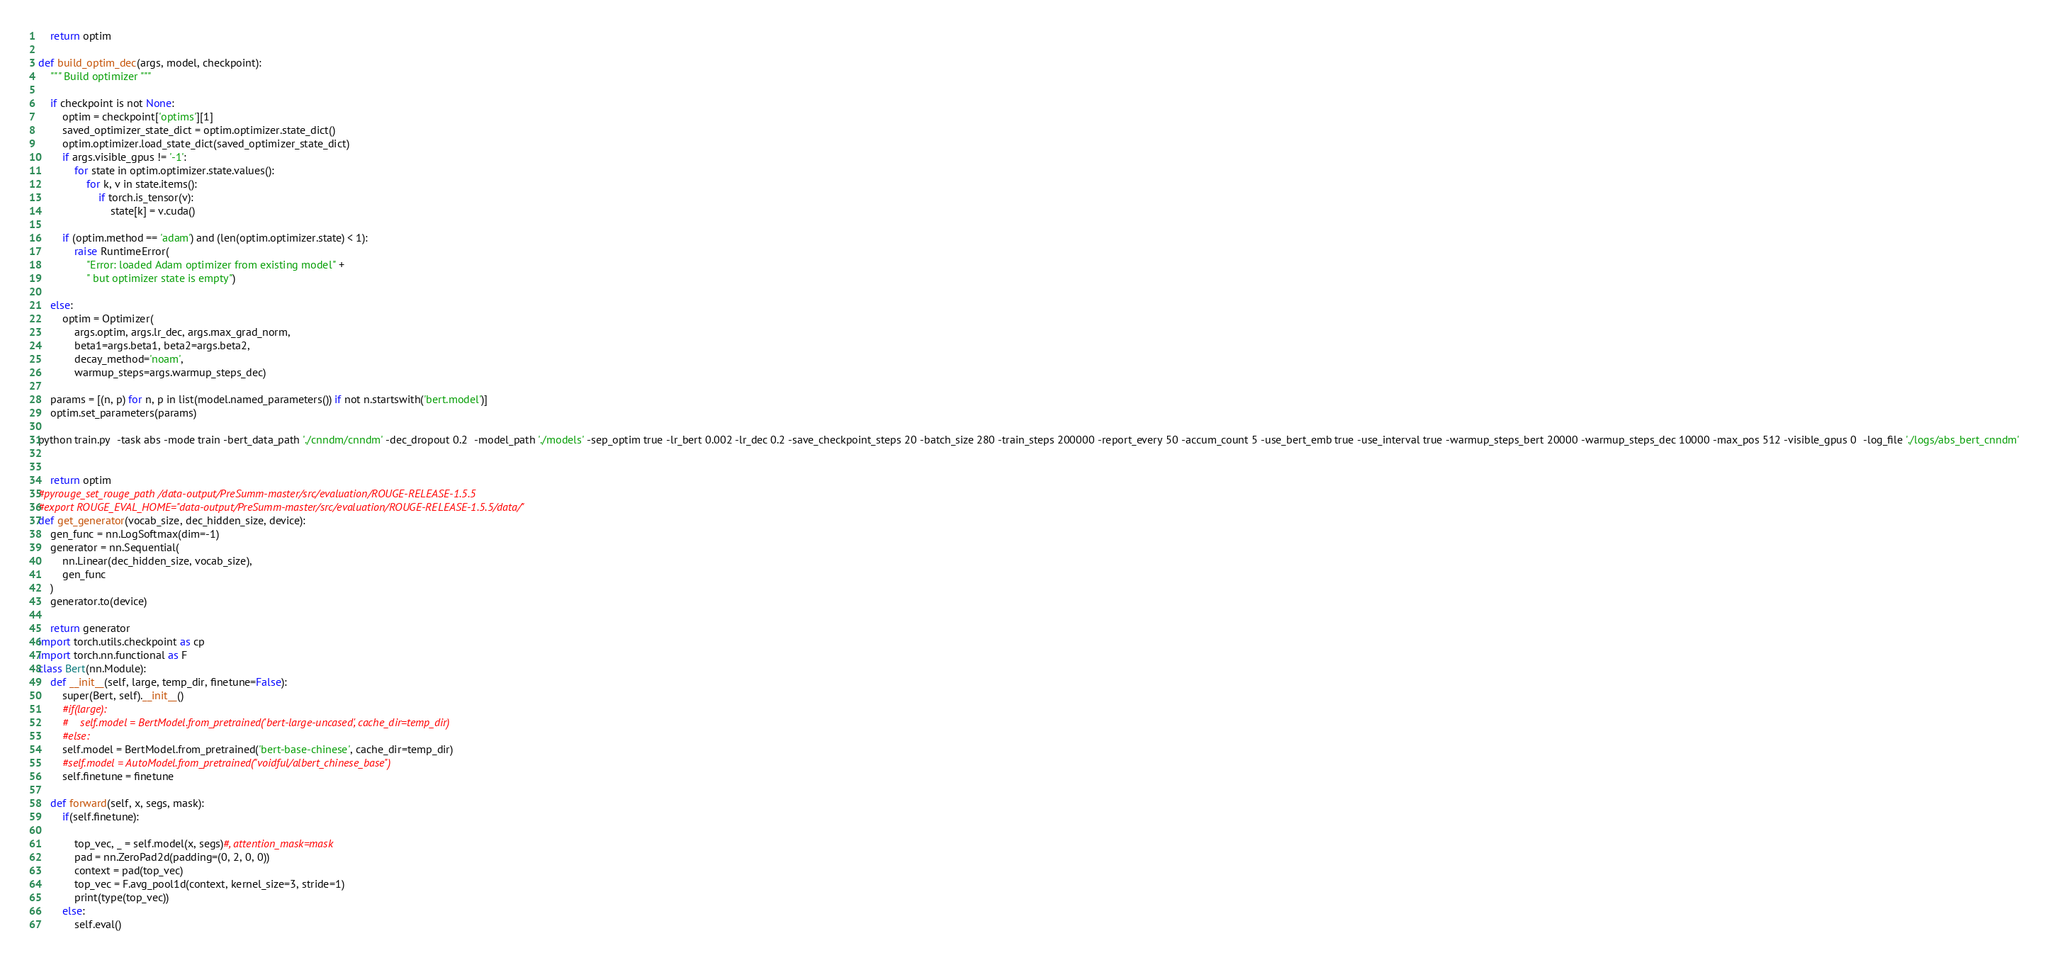Convert code to text. <code><loc_0><loc_0><loc_500><loc_500><_Python_>

    return optim

def build_optim_dec(args, model, checkpoint):
    """ Build optimizer """

    if checkpoint is not None:
        optim = checkpoint['optims'][1]
        saved_optimizer_state_dict = optim.optimizer.state_dict()
        optim.optimizer.load_state_dict(saved_optimizer_state_dict)
        if args.visible_gpus != '-1':
            for state in optim.optimizer.state.values():
                for k, v in state.items():
                    if torch.is_tensor(v):
                        state[k] = v.cuda()

        if (optim.method == 'adam') and (len(optim.optimizer.state) < 1):
            raise RuntimeError(
                "Error: loaded Adam optimizer from existing model" +
                " but optimizer state is empty")

    else:
        optim = Optimizer(
            args.optim, args.lr_dec, args.max_grad_norm,
            beta1=args.beta1, beta2=args.beta2,
            decay_method='noam',
            warmup_steps=args.warmup_steps_dec)

    params = [(n, p) for n, p in list(model.named_parameters()) if not n.startswith('bert.model')]
    optim.set_parameters(params)

python train.py  -task abs -mode train -bert_data_path './cnndm/cnndm' -dec_dropout 0.2  -model_path './models' -sep_optim true -lr_bert 0.002 -lr_dec 0.2 -save_checkpoint_steps 20 -batch_size 280 -train_steps 200000 -report_every 50 -accum_count 5 -use_bert_emb true -use_interval true -warmup_steps_bert 20000 -warmup_steps_dec 10000 -max_pos 512 -visible_gpus 0  -log_file './logs/abs_bert_cnndm'


    return optim
#pyrouge_set_rouge_path /data-output/PreSumm-master/src/evaluation/ROUGE-RELEASE-1.5.5
#export ROUGE_EVAL_HOME="data-output/PreSumm-master/src/evaluation/ROUGE-RELEASE-1.5.5/data/"
def get_generator(vocab_size, dec_hidden_size, device):
    gen_func = nn.LogSoftmax(dim=-1)
    generator = nn.Sequential(
        nn.Linear(dec_hidden_size, vocab_size),
        gen_func
    )
    generator.to(device)

    return generator
import torch.utils.checkpoint as cp
import torch.nn.functional as F
class Bert(nn.Module):
    def __init__(self, large, temp_dir, finetune=False):
        super(Bert, self).__init__()
        #if(large):
        #    self.model = BertModel.from_pretrained('bert-large-uncased', cache_dir=temp_dir)
        #else:
        self.model = BertModel.from_pretrained('bert-base-chinese', cache_dir=temp_dir)
        #self.model = AutoModel.from_pretrained("voidful/albert_chinese_base")
        self.finetune = finetune

    def forward(self, x, segs, mask):
        if(self.finetune):

            top_vec, _ = self.model(x, segs)#, attention_mask=mask
            pad = nn.ZeroPad2d(padding=(0, 2, 0, 0))
            context = pad(top_vec)
            top_vec = F.avg_pool1d(context, kernel_size=3, stride=1)
            print(type(top_vec))
        else:
            self.eval()</code> 